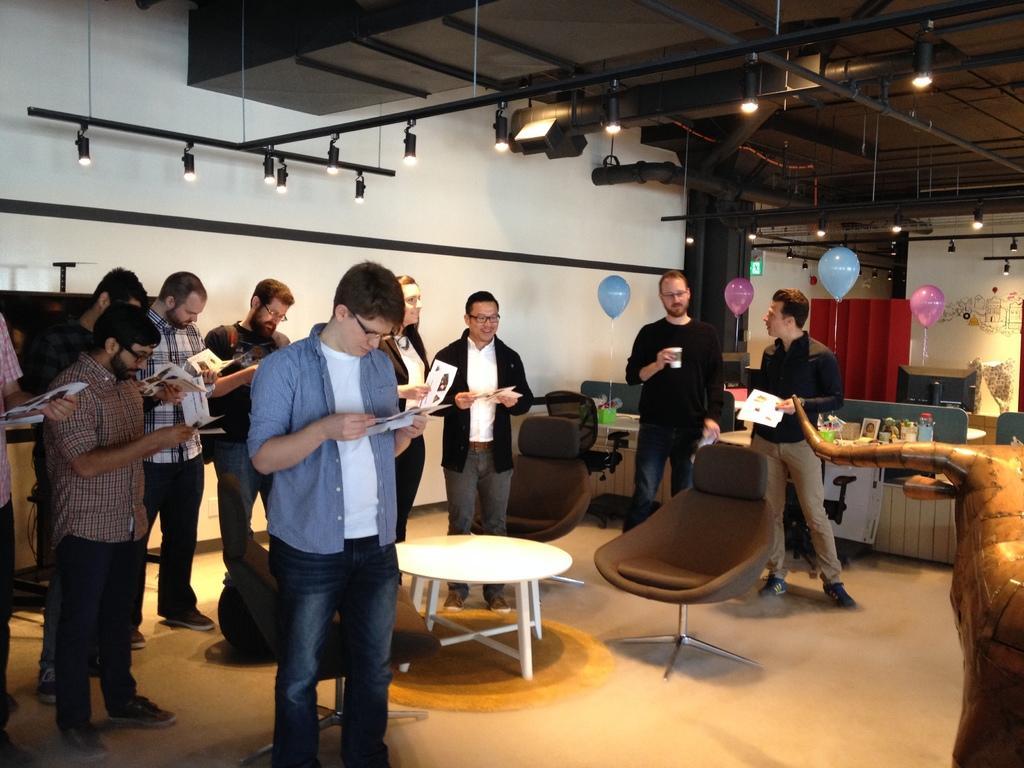Can you describe this image briefly? In this picture we can see some persons are standing on the floor and looking in to the paper. This is table and these are the chairs. And he hold a glass with his hand. These are the balloons. And on the background there is a wall. And these are the lights. 